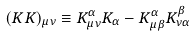<formula> <loc_0><loc_0><loc_500><loc_500>( K K ) _ { \mu \nu } \equiv K ^ { \alpha } _ { \mu \nu } K _ { \alpha } - K ^ { \alpha } _ { \mu \beta } K ^ { \beta } _ { \nu \alpha }</formula> 